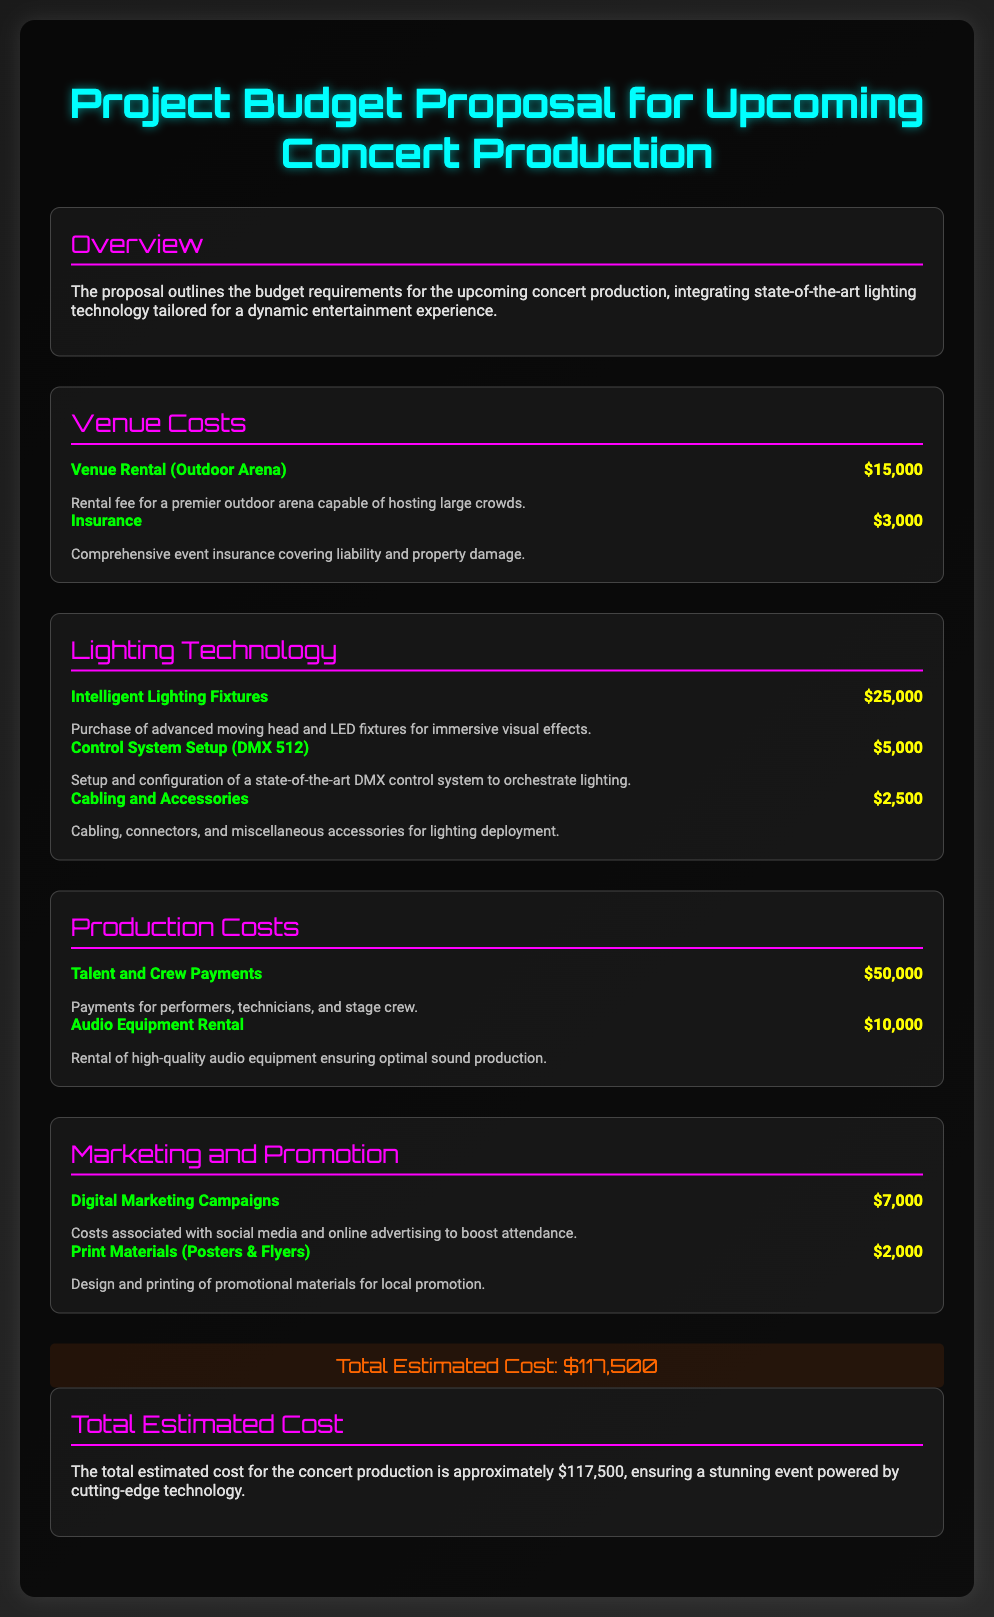What is the total estimated cost? The total estimated cost is stated in the document as approximately $117,500.
Answer: $117,500 What are the venue rental costs? The document lists the venue rental cost as $15,000 for an outdoor arena rental.
Answer: $15,000 How much is allocated for intelligent lighting fixtures? The proposal specifies $25,000 for the purchase of intelligent lighting fixtures.
Answer: $25,000 What is the expense for the digital marketing campaigns? The document mentions $7,000 allocated for digital marketing campaigns.
Answer: $7,000 How much is spent on talent and crew payments? The talent and crew payments total is indicated as $50,000 in the document.
Answer: $50,000 What type of control system is being set up? The document specifies a DMX 512 control system is being set up.
Answer: DMX 512 What is the cost of audio equipment rental? The audio equipment rental cost is stated as $10,000 in the proposal.
Answer: $10,000 What is included in the cabling and accessories cost? The document includes cabling, connectors, and miscellaneous accessories for lighting deployment under this cost of $2,500.
Answer: $2,500 How much is allocated for advertising print materials? The amount set aside for print materials is specified as $2,000.
Answer: $2,000 What is the total amount for insurance? The insurance cost is mentioned as $3,000 for comprehensive event coverage.
Answer: $3,000 